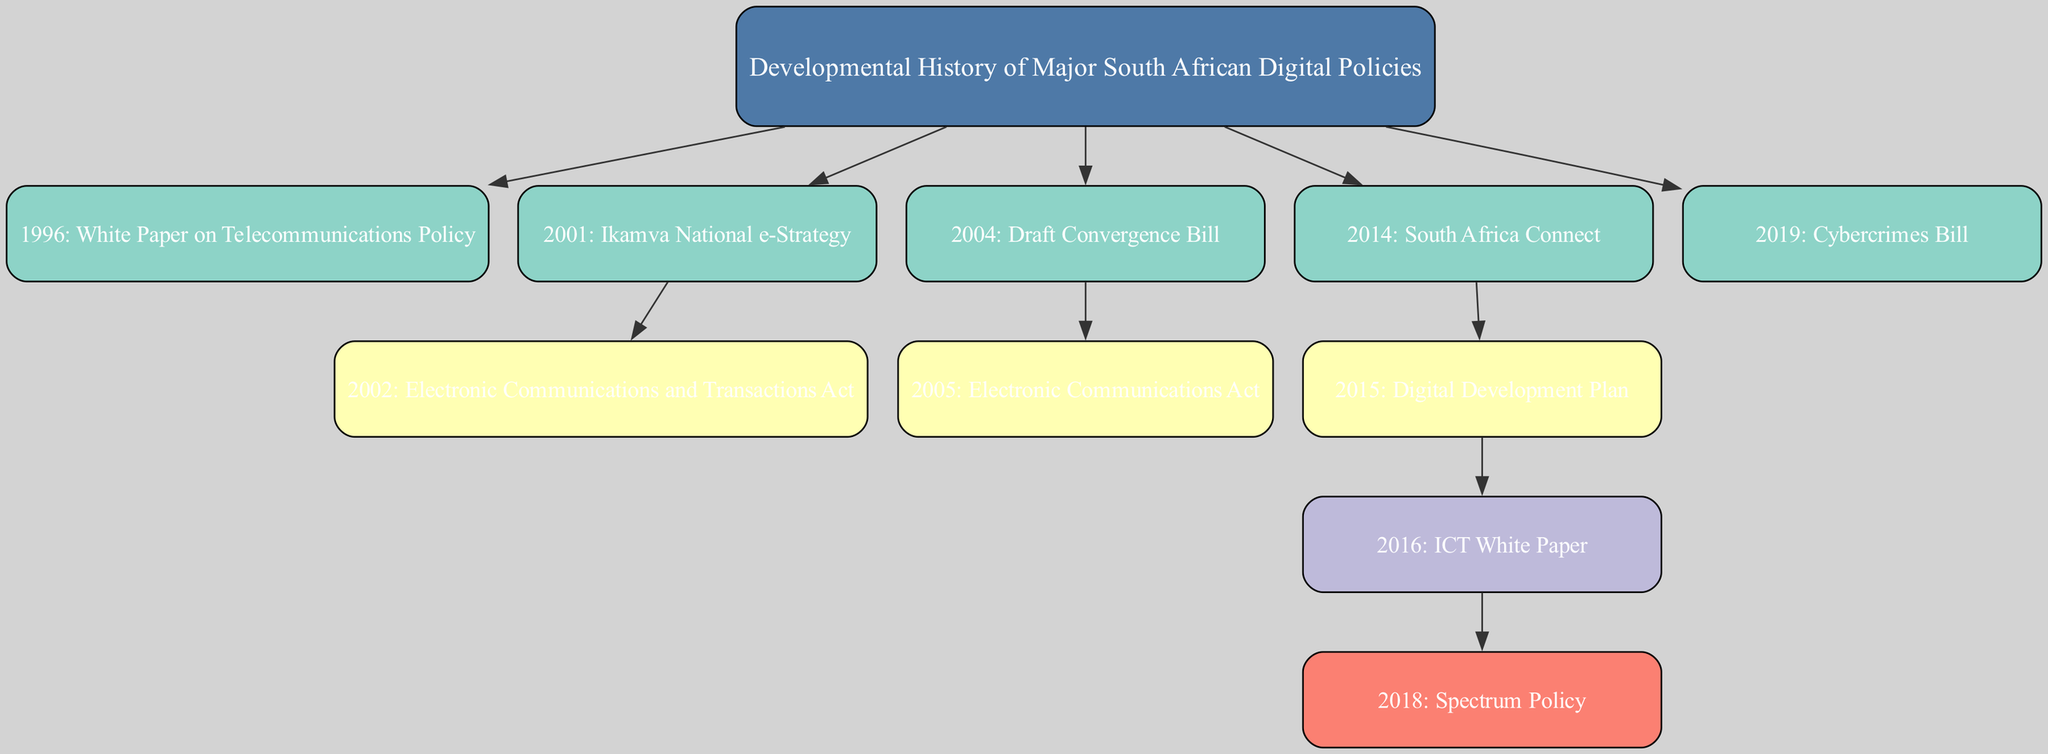What is the first digital policy listed in the diagram? The first digital policy shown in the diagram is at the top of the tree, identified as "1996: White Paper on Telecommunications Policy".
Answer: 1996: White Paper on Telecommunications Policy How many major digital policies are shown in the diagram? Counting all the nodes in the diagram, there are a total of 7 major digital policies represented.
Answer: 7 Which policy was created immediately after the Ikamva National e-Strategy? In the diagram, the "2002: Electronic Communications and Transactions Act" is nested under the "2001: Ikamva National e-Strategy", showing it was the next policy created following it.
Answer: 2002: Electronic Communications and Transactions Act What is the relationship between the "2014: South Africa Connect" and "2015: Digital Development Plan"? "2015: Digital Development Plan" is a child node that is directly under "2014: South Africa Connect", indicating that the Digital Development Plan stems from South Africa Connect.
Answer: Child How many policies are listed under the "2016: ICT White Paper"? The only policy under the "2016: ICT White Paper" is "2018: Spectrum Policy", making the count one.
Answer: 1 What is the last major digital policy mentioned in the diagram? The last policy is found at the bottom of the tree structure, identified as "2019: Cybercrimes Bill".
Answer: 2019: Cybercrimes Bill Which act is associated with the Draft Convergence Bill from 2004? The "2005: Electronic Communications Act" is the act associated with the "2004: Draft Convergence Bill", as it is a direct subsequent child in the family tree.
Answer: 2005: Electronic Communications Act Which policy was introduced before the Spectrum Policy? The "2016: ICT White Paper" is the policy introduced immediately before the "2018: Spectrum Policy" in the hierarchy of the diagram.
Answer: 2016: ICT White Paper 